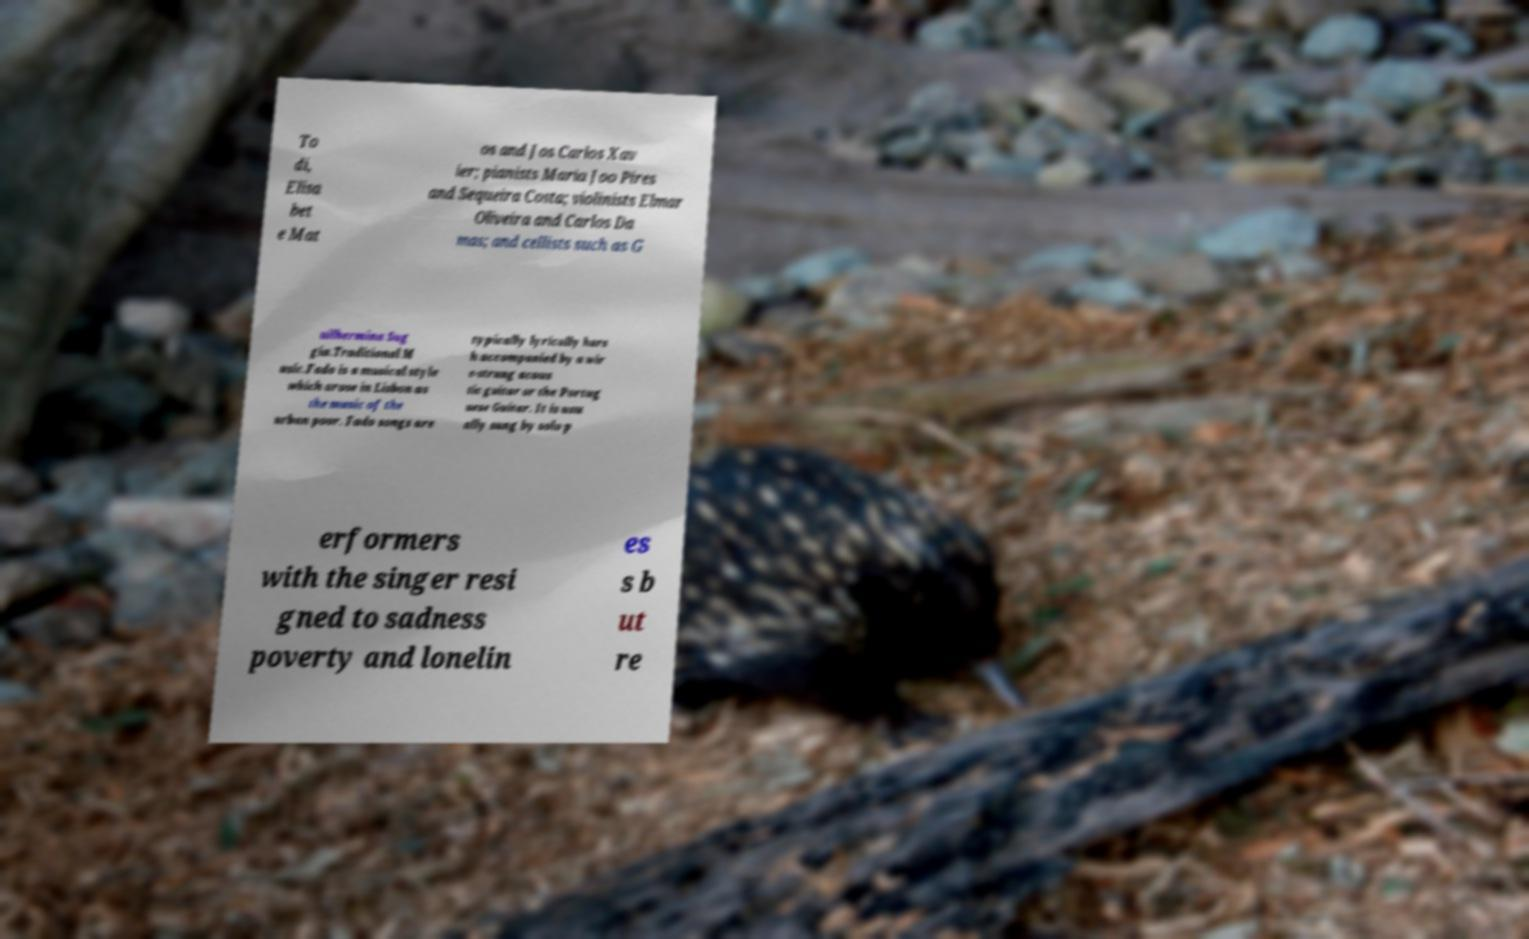For documentation purposes, I need the text within this image transcribed. Could you provide that? To di, Elisa bet e Mat os and Jos Carlos Xav ier; pianists Maria Joo Pires and Sequeira Costa; violinists Elmar Oliveira and Carlos Da mas; and cellists such as G uilhermina Sug gia.Traditional M usic.Fado is a musical style which arose in Lisbon as the music of the urban poor. Fado songs are typically lyrically hars h accompanied by a wir e-strung acous tic guitar or the Portug uese Guitar. It is usu ally sung by solo p erformers with the singer resi gned to sadness poverty and lonelin es s b ut re 